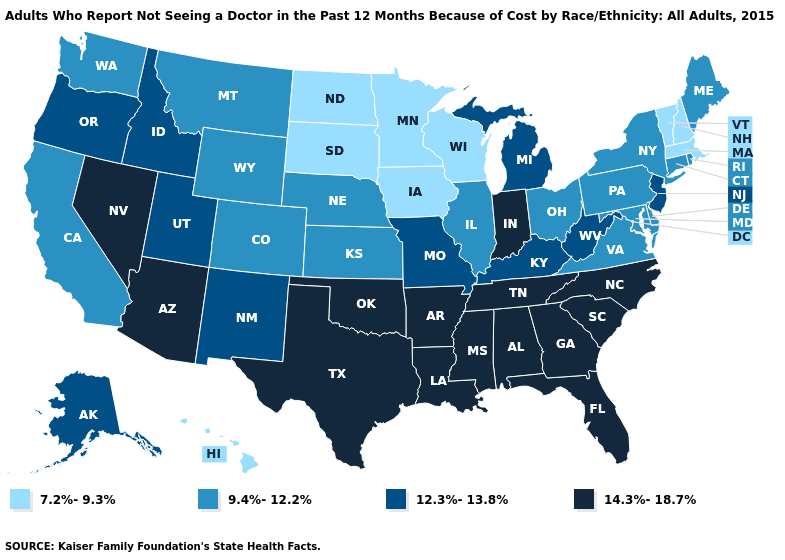Does Wisconsin have the lowest value in the MidWest?
Write a very short answer. Yes. Name the states that have a value in the range 14.3%-18.7%?
Quick response, please. Alabama, Arizona, Arkansas, Florida, Georgia, Indiana, Louisiana, Mississippi, Nevada, North Carolina, Oklahoma, South Carolina, Tennessee, Texas. Name the states that have a value in the range 7.2%-9.3%?
Concise answer only. Hawaii, Iowa, Massachusetts, Minnesota, New Hampshire, North Dakota, South Dakota, Vermont, Wisconsin. Which states have the highest value in the USA?
Keep it brief. Alabama, Arizona, Arkansas, Florida, Georgia, Indiana, Louisiana, Mississippi, Nevada, North Carolina, Oklahoma, South Carolina, Tennessee, Texas. Among the states that border New Jersey , which have the highest value?
Quick response, please. Delaware, New York, Pennsylvania. What is the value of Rhode Island?
Answer briefly. 9.4%-12.2%. Which states have the highest value in the USA?
Write a very short answer. Alabama, Arizona, Arkansas, Florida, Georgia, Indiana, Louisiana, Mississippi, Nevada, North Carolina, Oklahoma, South Carolina, Tennessee, Texas. Does Connecticut have the highest value in the USA?
Write a very short answer. No. Among the states that border Montana , which have the highest value?
Keep it brief. Idaho. Among the states that border Arkansas , does Oklahoma have the highest value?
Quick response, please. Yes. Does Texas have the highest value in the USA?
Be succinct. Yes. Name the states that have a value in the range 14.3%-18.7%?
Give a very brief answer. Alabama, Arizona, Arkansas, Florida, Georgia, Indiana, Louisiana, Mississippi, Nevada, North Carolina, Oklahoma, South Carolina, Tennessee, Texas. Which states have the highest value in the USA?
Short answer required. Alabama, Arizona, Arkansas, Florida, Georgia, Indiana, Louisiana, Mississippi, Nevada, North Carolina, Oklahoma, South Carolina, Tennessee, Texas. What is the highest value in the Northeast ?
Concise answer only. 12.3%-13.8%. Does Pennsylvania have a lower value than Iowa?
Answer briefly. No. 